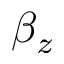Convert formula to latex. <formula><loc_0><loc_0><loc_500><loc_500>\beta _ { z }</formula> 